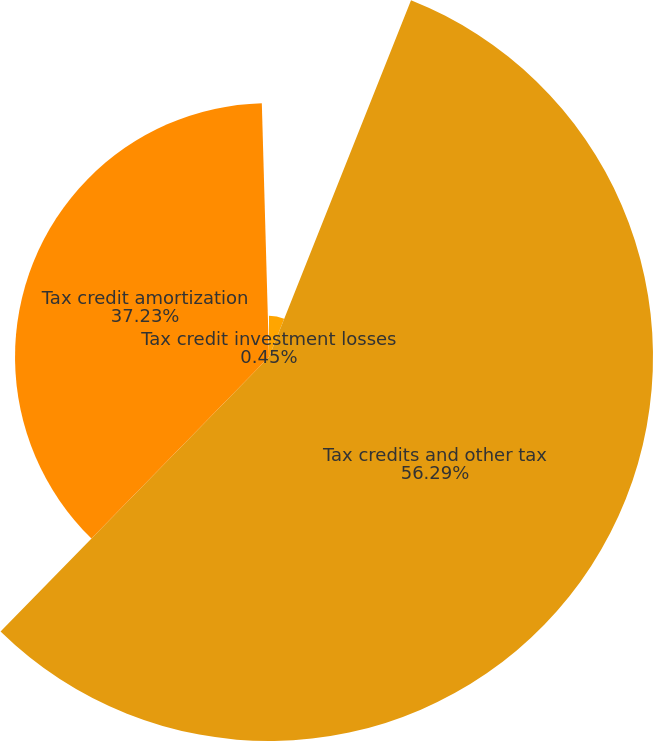<chart> <loc_0><loc_0><loc_500><loc_500><pie_chart><fcel>(dollar amounts in thousands)<fcel>Tax credits and other tax<fcel>Tax credit amortization<fcel>Tax credit investment losses<nl><fcel>6.03%<fcel>56.29%<fcel>37.23%<fcel>0.45%<nl></chart> 